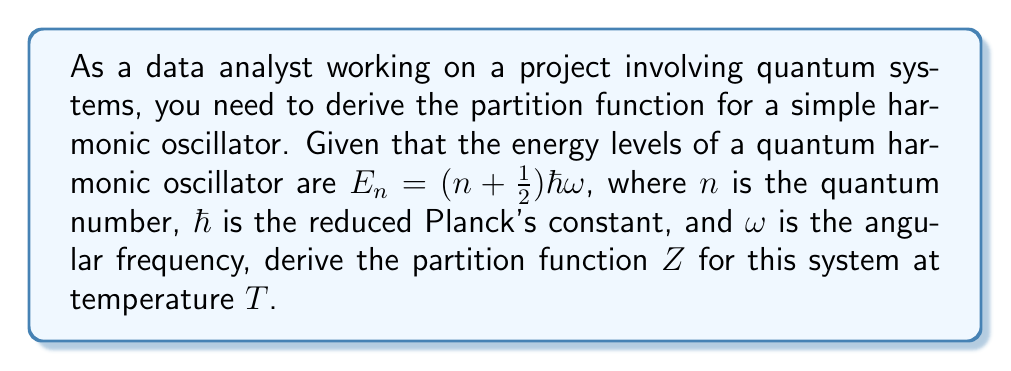Can you solve this math problem? Let's approach this step-by-step:

1) The partition function $Z$ is defined as the sum over all possible states:

   $$Z = \sum_{n=0}^{\infty} e^{-\beta E_n}$$

   where $\beta = \frac{1}{k_B T}$, $k_B$ is Boltzmann's constant, and $T$ is temperature.

2) Substitute the energy levels into the partition function:

   $$Z = \sum_{n=0}^{\infty} e^{-\beta (n + \frac{1}{2})\hbar\omega}$$

3) Factor out the constant term:

   $$Z = e^{-\beta \frac{1}{2}\hbar\omega} \sum_{n=0}^{\infty} e^{-\beta n\hbar\omega}$$

4) Let $x = e^{-\beta \hbar\omega}$. Then our sum becomes:

   $$Z = e^{-\beta \frac{1}{2}\hbar\omega} \sum_{n=0}^{\infty} x^n$$

5) This is a geometric series with $|x| < 1$. The sum of this series is:

   $$\sum_{n=0}^{\infty} x^n = \frac{1}{1-x}$$

6) Substituting back:

   $$Z = e^{-\beta \frac{1}{2}\hbar\omega} \frac{1}{1-e^{-\beta \hbar\omega}}$$

7) This can be simplified to:

   $$Z = \frac{e^{-\beta \frac{1}{2}\hbar\omega}}{1-e^{-\beta \hbar\omega}}$$

This is the partition function for a quantum harmonic oscillator.
Answer: $$Z = \frac{e^{-\beta \frac{1}{2}\hbar\omega}}{1-e^{-\beta \hbar\omega}}$$ 